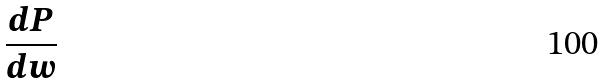<formula> <loc_0><loc_0><loc_500><loc_500>\frac { d P } { d w }</formula> 